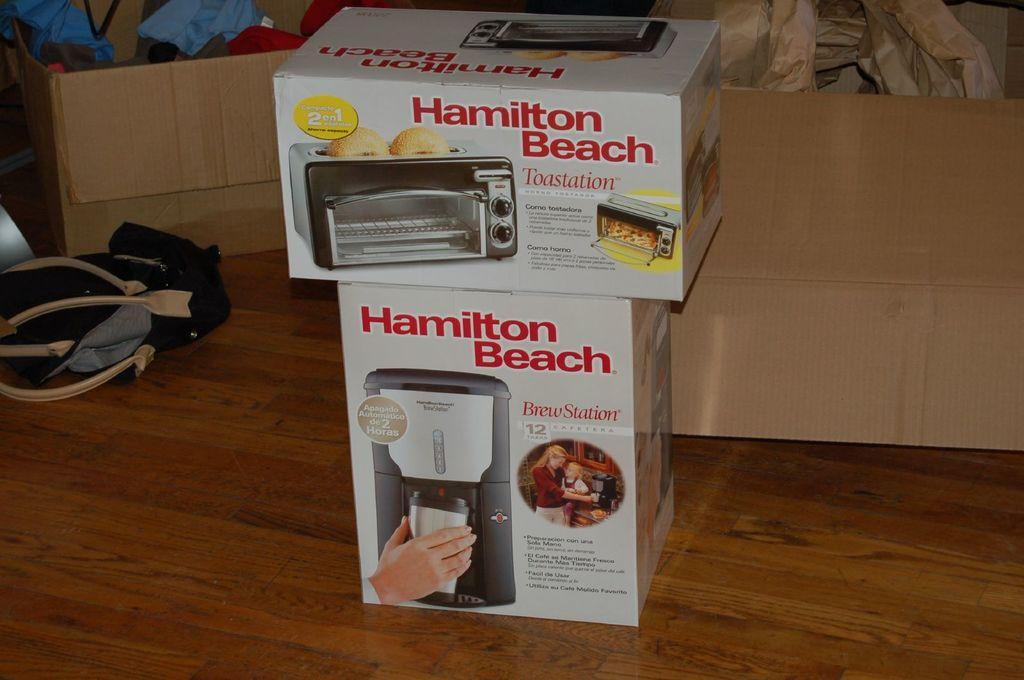What appliances are visible in the image? There is a toast making box and a brew station box in the image. What surface are the appliances placed on? Both boxes are placed on a wooden surface. What can be seen in the background of the image? There are two boxes with clothes in the background. What additional item is present beside the boxes? There is a handbag beside the boxes. What type of train is visible in the image? There is no train present in the image. How is the division of labor represented in the image? The image does not depict any division of labor; it shows appliances and other items on a wooden surface. 